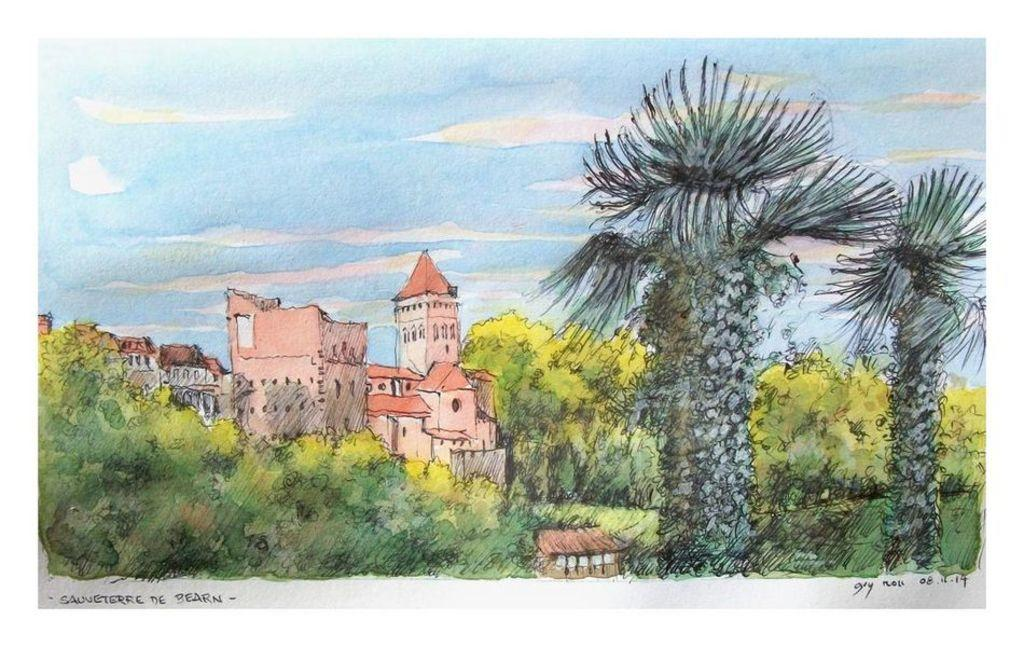What is visible in the background of the image? The sky is visible in the image. What can be seen in the sky? Clouds are present in the sky. What type of structures are in the image? There are buildings in the image. What type of vegetation is present in the image? Trees are present in the image. What type of ground cover is visible in the image? Grass is visible in the image. What type of mitten is being worn by the insect in the image? There is no insect or mitten present in the image. What type of flesh can be seen on the trees in the image? There is no flesh visible on the trees in the image; they are covered with bark and leaves. 